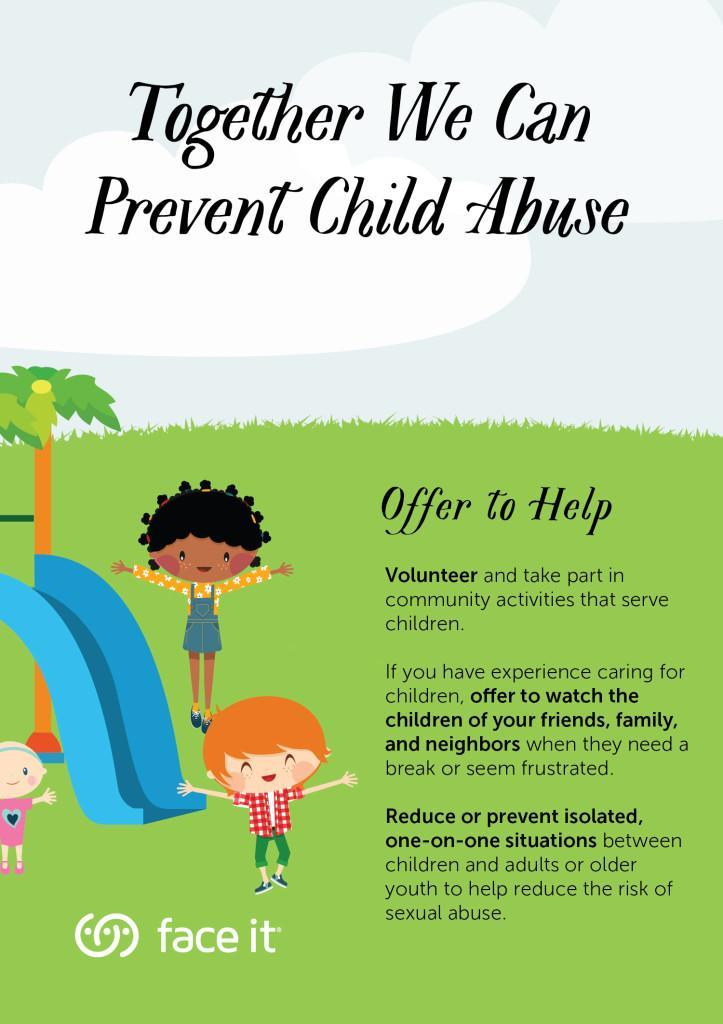What can be minimised, by preventing isolated situations between children and adults?
Answer the question with a short phrase. The risk of sexual abuse What is the colour of the slide - red, blue, yellow or pink? Blue Who can a person experienced in childcare help, when they need a break? Friends, family, and neighbours How can you help friends, family & neighbours, when they seem frustrated? Offer to watch the children How many children are shown here? 3 